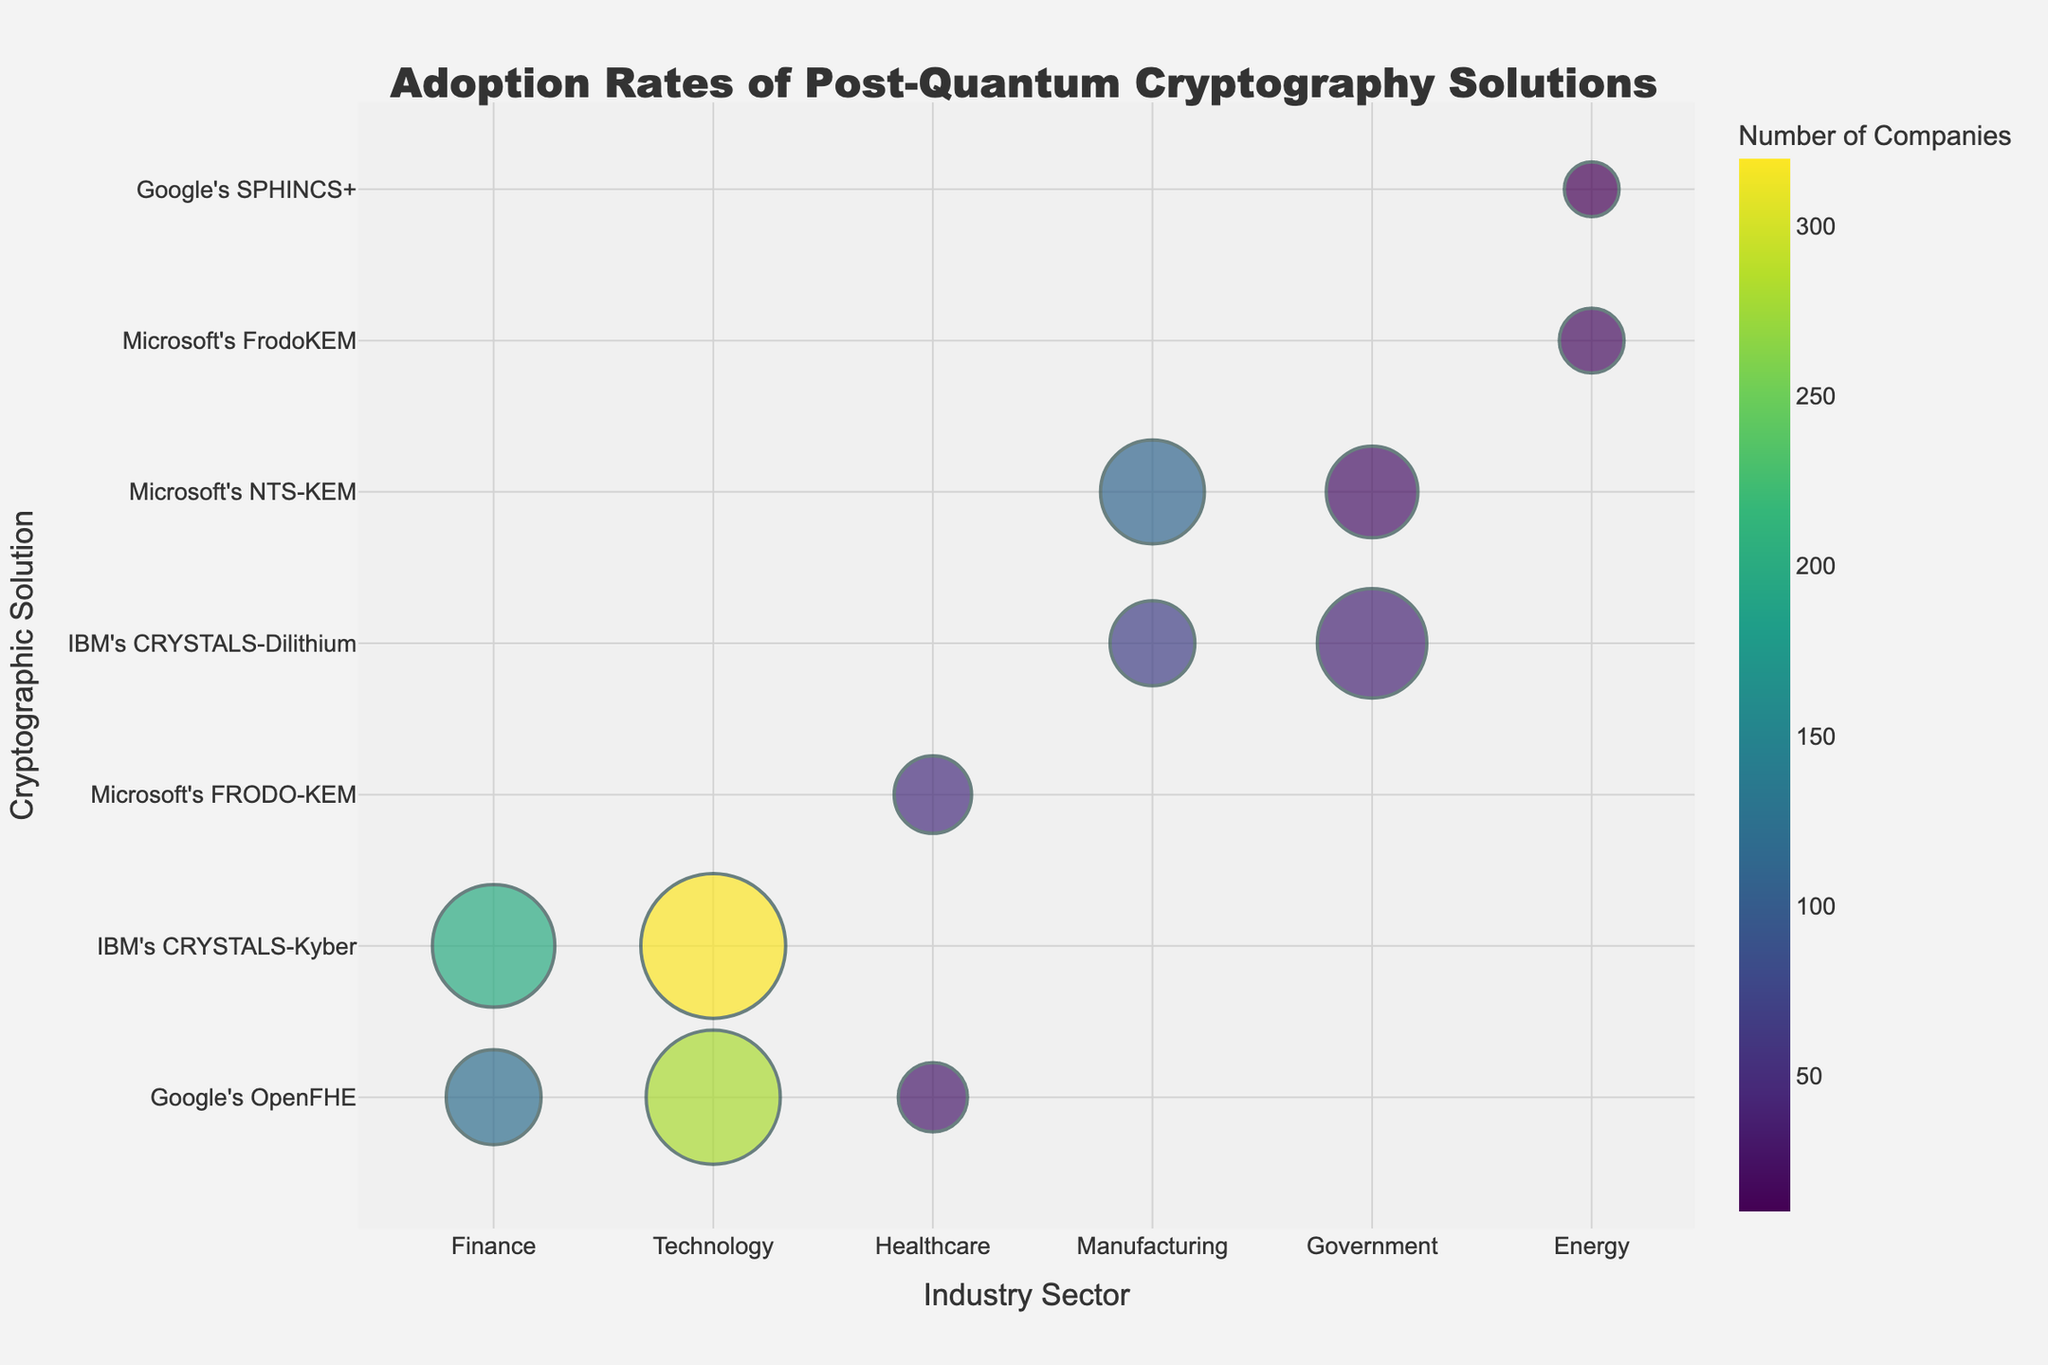What's the title of the chart? The title can be found at the top center of the chart. It reads "Adoption Rates of Post-Quantum Cryptography Solutions" in a prominent font.
Answer: Adoption Rates of Post-Quantum Cryptography Solutions What are the x-axis and y-axis labels of the chart? The x-axis label is "Industry Sector," and the y-axis label is "Cryptographic Solution." These labels describe what is represented on each axis.
Answer: Industry Sector; Cryptographic Solution Which industry sector has the highest adoption rate for Google's OpenFHE? To find this, look at the bubbles corresponding to Google's OpenFHE on the y-axis and compare their sizes across different industries. The Technology sector has the largest bubble for Google's OpenFHE.
Answer: Technology Which cryptographic solution has the highest number of companies adopting it in the Technology sector? In the Technology sector, compare the color intensity of the bubbles. IBM's CRYSTALS-Kyber has the darkest bubble, indicating the highest number of companies.
Answer: IBM's CRYSTALS-Kyber How many companies in the Finance sector have adopted IBM's CRYSTALS-Kyber? Hovering over or checking the specific bubble for IBM's CRYSTALS-Kyber in the Finance sector gives this information. It is represented by a dark bubble.
Answer: 200 Which sector has the lowest adoption rate, and which solution does it correspond to? Find the smallest bubble in the chart. The smallest bubble is for Google's SPHINCS+ in the Energy sector.
Answer: Energy for Google's SPHINCS+ How does the adoption rate of Microsoft's NTS-KEM in Manufacturing compare to its rate in Government? Compare the sizes of the bubbles for Microsoft's NTS-KEM in Manufacturing and Government. The Manufacturing bubble is larger than the Government bubble.
Answer: Manufacturing > Government What is the combined adoption rate of cryptographic solutions in the Healthcare sector? Add the adoption rates of Google's OpenFHE and Microsoft's FRODO-KEM in Healthcare. The rates are 8 and 10, respectively.
Answer: 18 Which cryptographic solution appears in the highest number of different industry sectors? Count how many different sectors each cryptographic solution is present in by checking the y-axis labels across industries. Google's OpenFHE appears in three sectors: Finance, Healthcare, and Technology.
Answer: Google's OpenFHE 